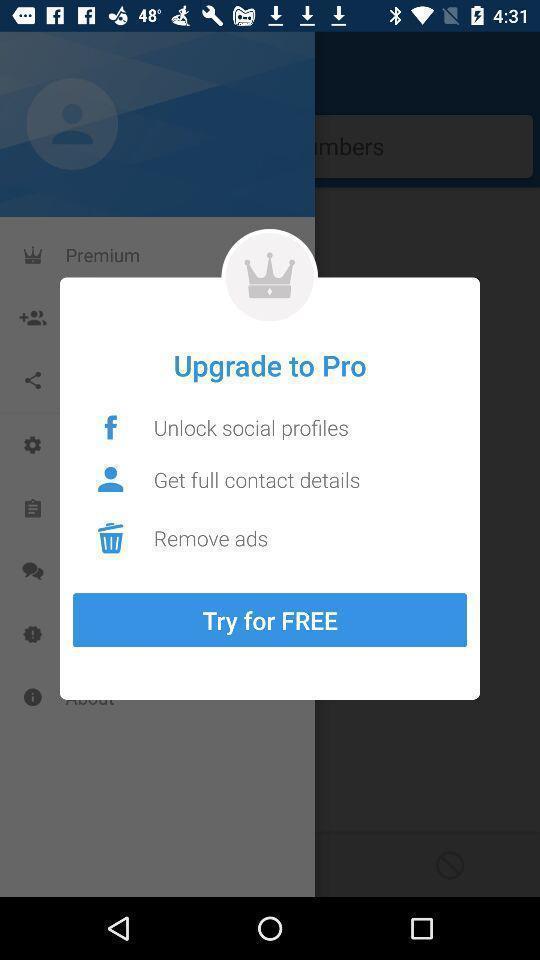Provide a description of this screenshot. Popup to upgrade an application. 